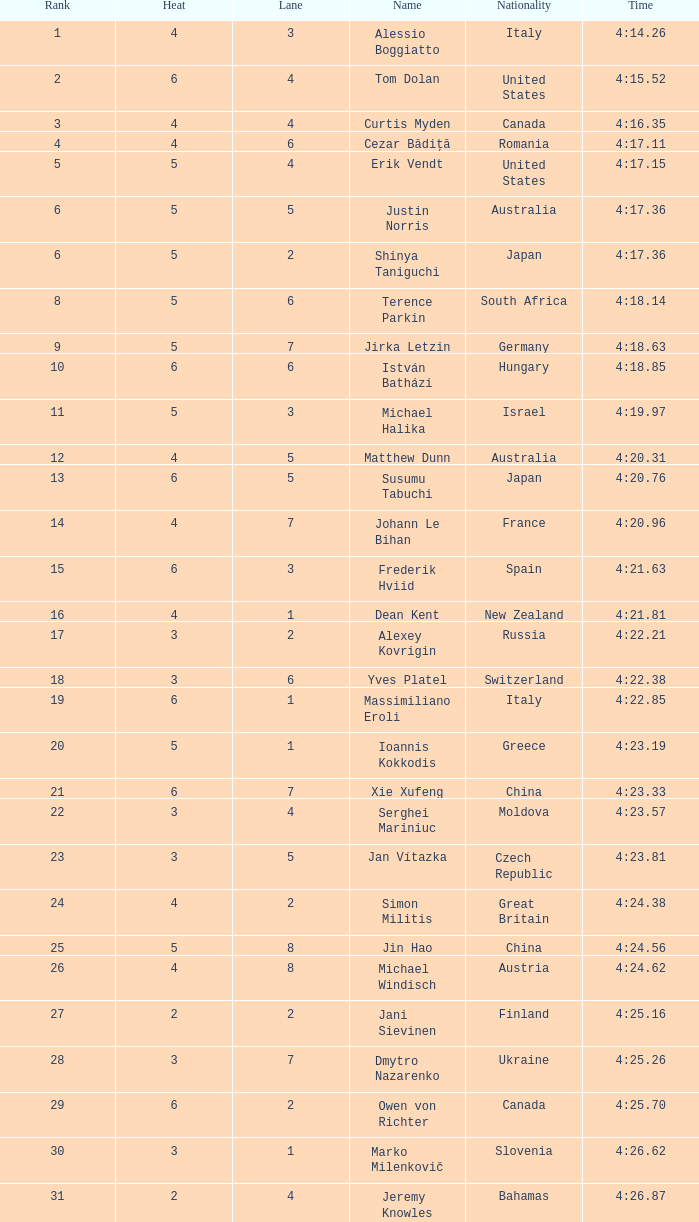Who was the 4-lane individual from canada? 4.0. 